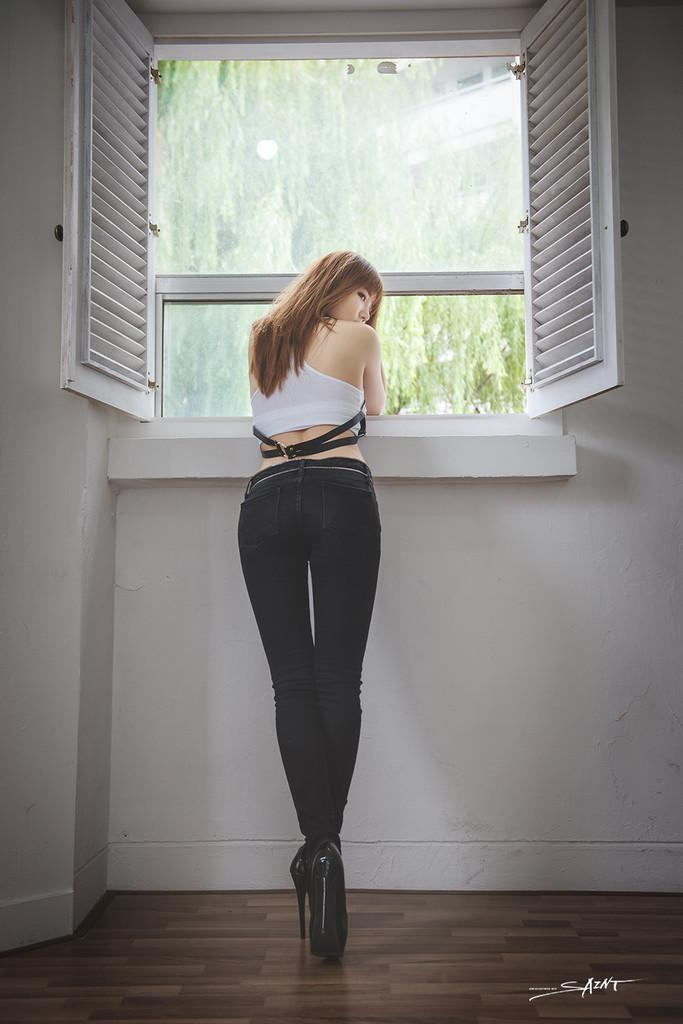What is the primary subject in the image? There is a woman standing in the image. Where is the woman standing? The woman is standing on the floor. What is near the woman in the image? The woman is near a window. Can you describe the window in the image? There is a window in the image, and it has window doors. What can be seen through the window glass? Trees and a building are visible through the window glass. What is the background of the image? There is a wall in the image. What type of knife is being used to cut the snow in the image? There is no snow or knife present in the image; it features a woman standing near a window with a view of trees and a building. 